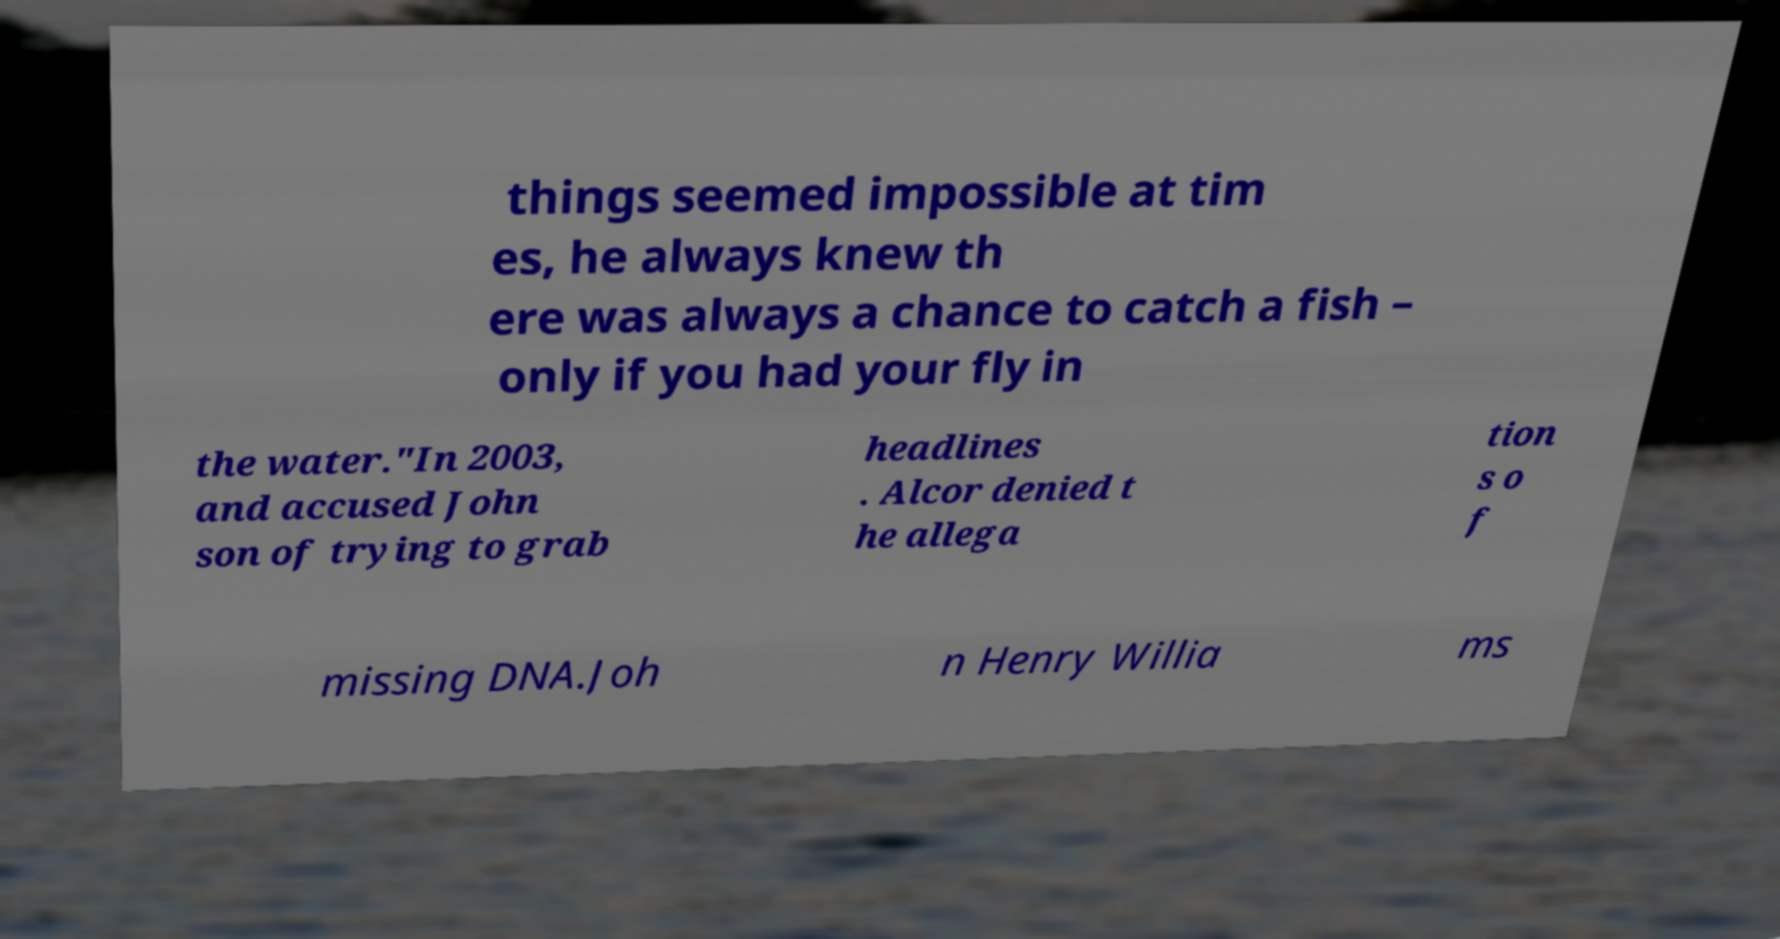Could you assist in decoding the text presented in this image and type it out clearly? things seemed impossible at tim es, he always knew th ere was always a chance to catch a fish – only if you had your fly in the water."In 2003, and accused John son of trying to grab headlines . Alcor denied t he allega tion s o f missing DNA.Joh n Henry Willia ms 